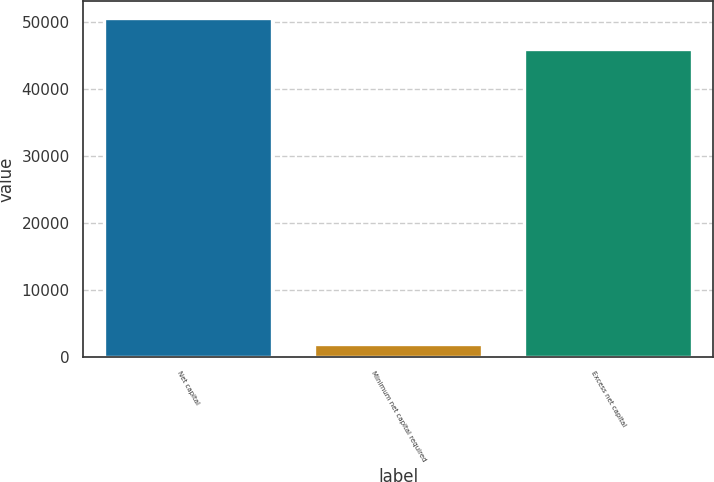<chart> <loc_0><loc_0><loc_500><loc_500><bar_chart><fcel>Net capital<fcel>Minimum net capital required<fcel>Excess net capital<nl><fcel>50671.5<fcel>1971<fcel>46065<nl></chart> 